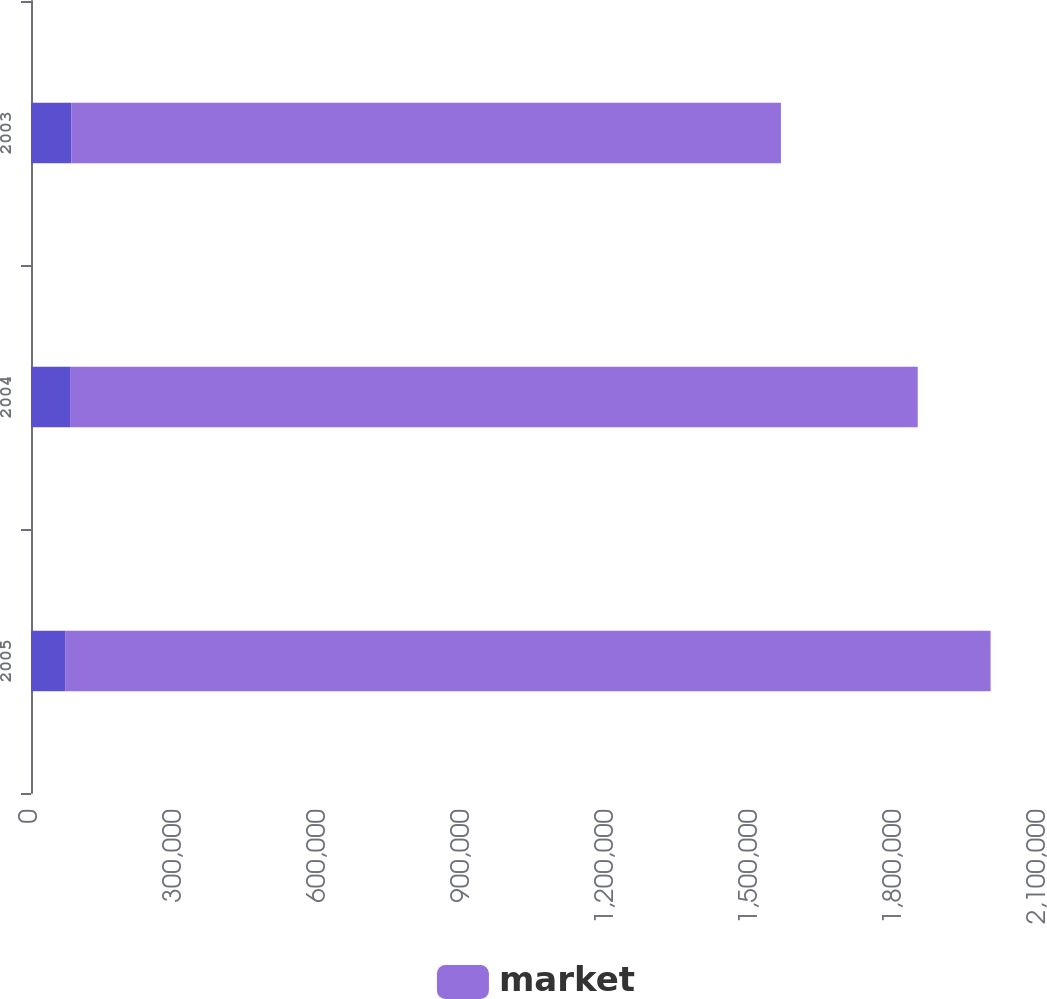Convert chart. <chart><loc_0><loc_0><loc_500><loc_500><stacked_bar_chart><ecel><fcel>2005<fcel>2004<fcel>2003<nl><fcel>nan<fcel>71125<fcel>81368<fcel>84366<nl><fcel>market<fcel>1.928e+06<fcel>1.766e+06<fcel>1.478e+06<nl></chart> 